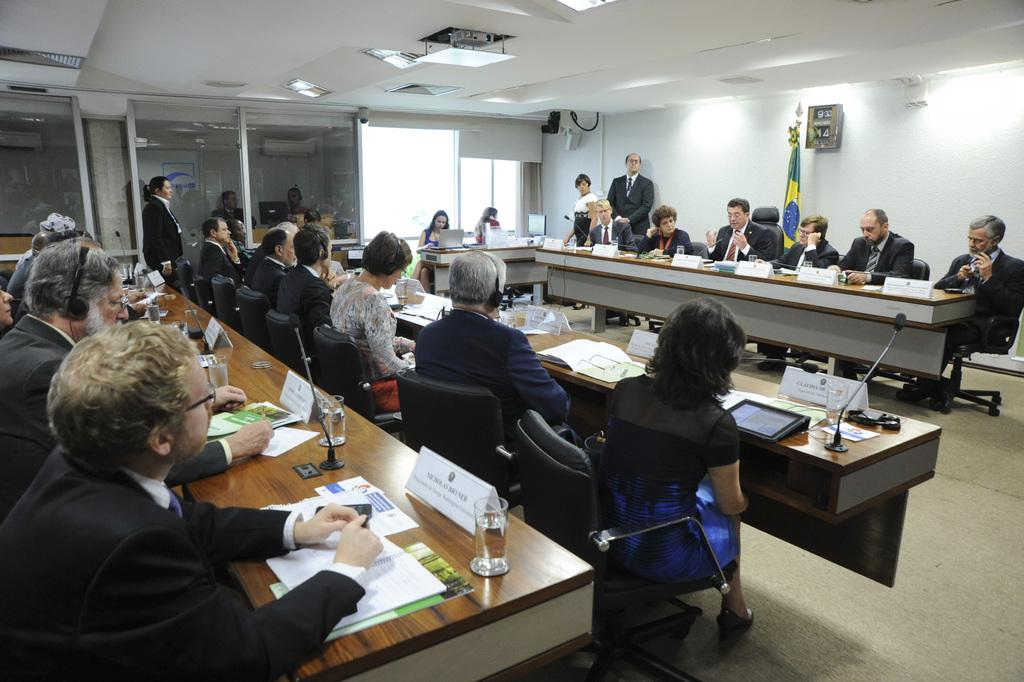What are the people near the table doing in the image? The people sitting on chairs near the table suggest they might be engaged in a meeting or discussion. What items can be seen on the table? There are papers, a glass, and a mic on the table. What type of window is present in the image? There is a glass window in the image. What is the purpose of the flag in the image? The flag in the image might represent a country, organization, or event. How many balls are visible on the table in the image? There are no balls present on the table in the image. What type of pocket can be seen on the people sitting near the table? There is no mention of pockets on the people sitting near the table in the image. 